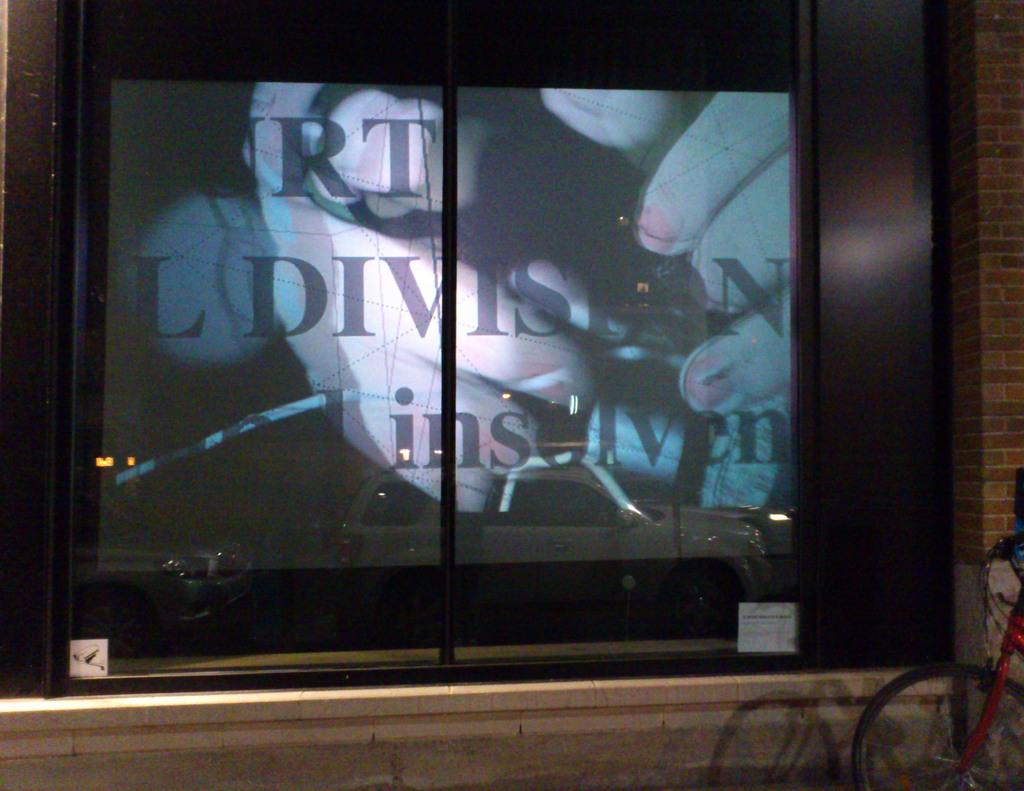What letter is before the word division?
Your answer should be very brief. L. 